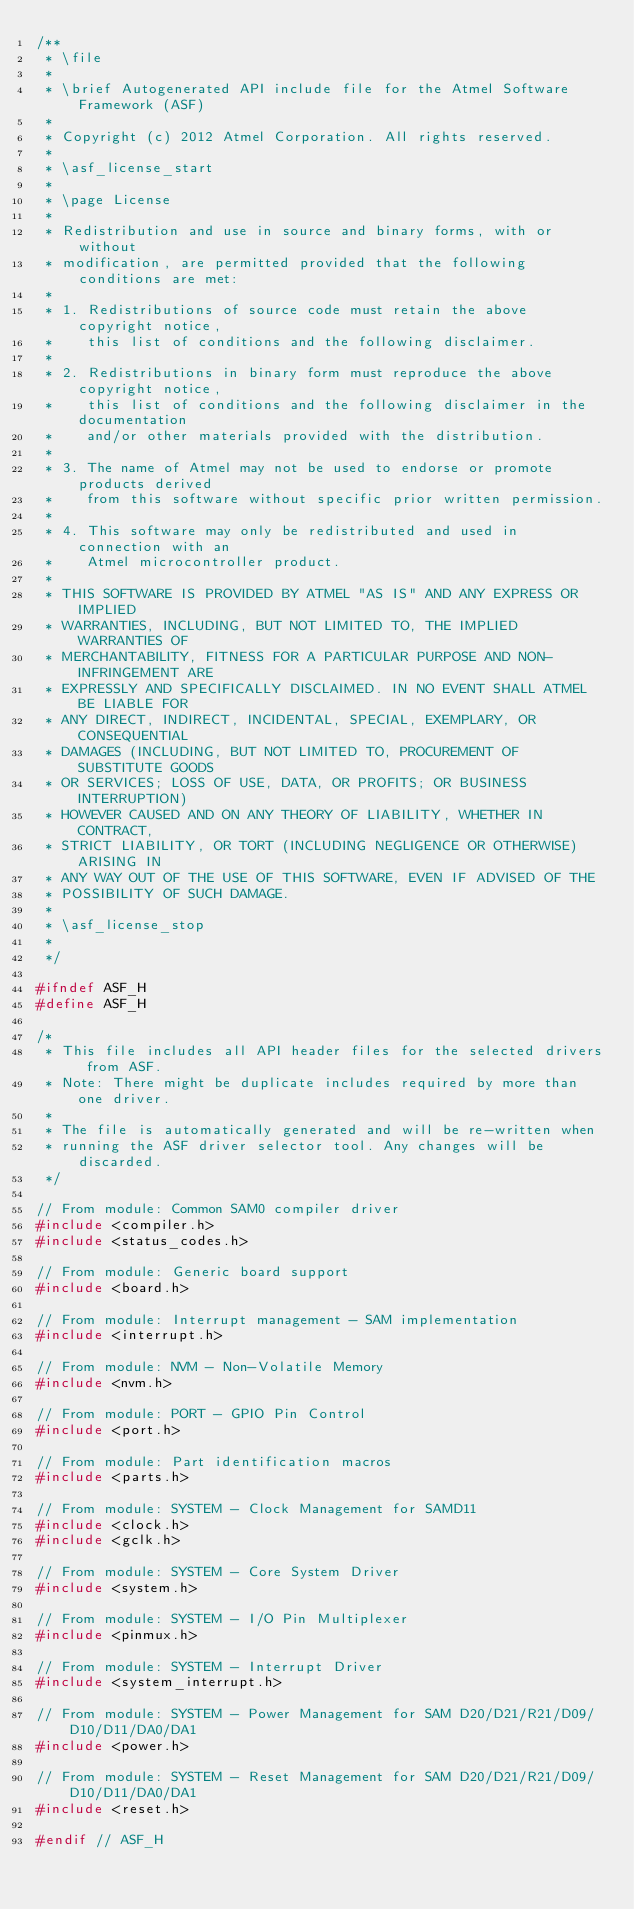Convert code to text. <code><loc_0><loc_0><loc_500><loc_500><_C_>/**
 * \file
 *
 * \brief Autogenerated API include file for the Atmel Software Framework (ASF)
 *
 * Copyright (c) 2012 Atmel Corporation. All rights reserved.
 *
 * \asf_license_start
 *
 * \page License
 *
 * Redistribution and use in source and binary forms, with or without
 * modification, are permitted provided that the following conditions are met:
 *
 * 1. Redistributions of source code must retain the above copyright notice,
 *    this list of conditions and the following disclaimer.
 *
 * 2. Redistributions in binary form must reproduce the above copyright notice,
 *    this list of conditions and the following disclaimer in the documentation
 *    and/or other materials provided with the distribution.
 *
 * 3. The name of Atmel may not be used to endorse or promote products derived
 *    from this software without specific prior written permission.
 *
 * 4. This software may only be redistributed and used in connection with an
 *    Atmel microcontroller product.
 *
 * THIS SOFTWARE IS PROVIDED BY ATMEL "AS IS" AND ANY EXPRESS OR IMPLIED
 * WARRANTIES, INCLUDING, BUT NOT LIMITED TO, THE IMPLIED WARRANTIES OF
 * MERCHANTABILITY, FITNESS FOR A PARTICULAR PURPOSE AND NON-INFRINGEMENT ARE
 * EXPRESSLY AND SPECIFICALLY DISCLAIMED. IN NO EVENT SHALL ATMEL BE LIABLE FOR
 * ANY DIRECT, INDIRECT, INCIDENTAL, SPECIAL, EXEMPLARY, OR CONSEQUENTIAL
 * DAMAGES (INCLUDING, BUT NOT LIMITED TO, PROCUREMENT OF SUBSTITUTE GOODS
 * OR SERVICES; LOSS OF USE, DATA, OR PROFITS; OR BUSINESS INTERRUPTION)
 * HOWEVER CAUSED AND ON ANY THEORY OF LIABILITY, WHETHER IN CONTRACT,
 * STRICT LIABILITY, OR TORT (INCLUDING NEGLIGENCE OR OTHERWISE) ARISING IN
 * ANY WAY OUT OF THE USE OF THIS SOFTWARE, EVEN IF ADVISED OF THE
 * POSSIBILITY OF SUCH DAMAGE.
 *
 * \asf_license_stop
 *
 */

#ifndef ASF_H
#define ASF_H

/*
 * This file includes all API header files for the selected drivers from ASF.
 * Note: There might be duplicate includes required by more than one driver.
 *
 * The file is automatically generated and will be re-written when
 * running the ASF driver selector tool. Any changes will be discarded.
 */

// From module: Common SAM0 compiler driver
#include <compiler.h>
#include <status_codes.h>

// From module: Generic board support
#include <board.h>

// From module: Interrupt management - SAM implementation
#include <interrupt.h>

// From module: NVM - Non-Volatile Memory
#include <nvm.h>

// From module: PORT - GPIO Pin Control
#include <port.h>

// From module: Part identification macros
#include <parts.h>

// From module: SYSTEM - Clock Management for SAMD11
#include <clock.h>
#include <gclk.h>

// From module: SYSTEM - Core System Driver
#include <system.h>

// From module: SYSTEM - I/O Pin Multiplexer
#include <pinmux.h>

// From module: SYSTEM - Interrupt Driver
#include <system_interrupt.h>

// From module: SYSTEM - Power Management for SAM D20/D21/R21/D09/D10/D11/DA0/DA1
#include <power.h>

// From module: SYSTEM - Reset Management for SAM D20/D21/R21/D09/D10/D11/DA0/DA1
#include <reset.h>

#endif // ASF_H
</code> 